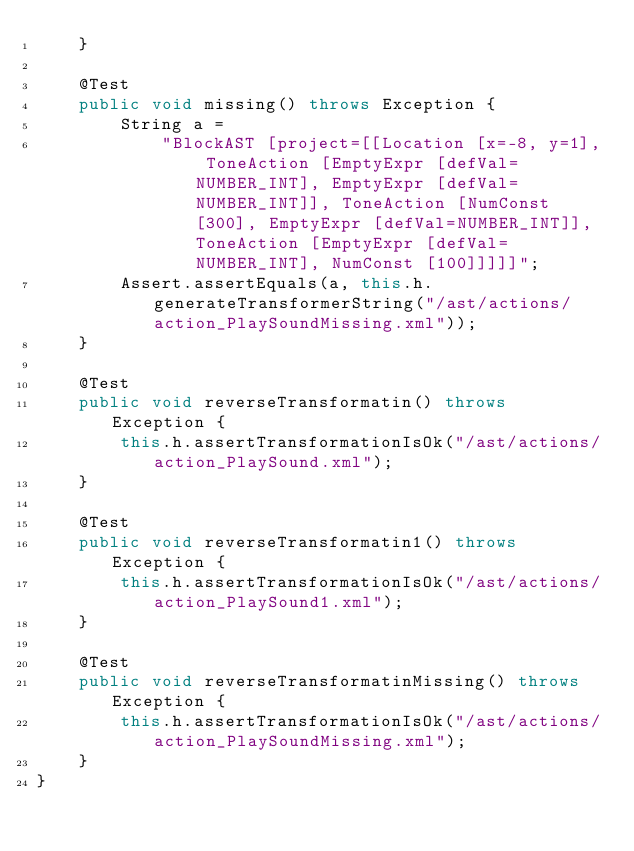<code> <loc_0><loc_0><loc_500><loc_500><_Java_>    }

    @Test
    public void missing() throws Exception {
        String a =
            "BlockAST [project=[[Location [x=-8, y=1], ToneAction [EmptyExpr [defVal=NUMBER_INT], EmptyExpr [defVal=NUMBER_INT]], ToneAction [NumConst [300], EmptyExpr [defVal=NUMBER_INT]], ToneAction [EmptyExpr [defVal=NUMBER_INT], NumConst [100]]]]]";
        Assert.assertEquals(a, this.h.generateTransformerString("/ast/actions/action_PlaySoundMissing.xml"));
    }

    @Test
    public void reverseTransformatin() throws Exception {
        this.h.assertTransformationIsOk("/ast/actions/action_PlaySound.xml");
    }

    @Test
    public void reverseTransformatin1() throws Exception {
        this.h.assertTransformationIsOk("/ast/actions/action_PlaySound1.xml");
    }

    @Test
    public void reverseTransformatinMissing() throws Exception {
        this.h.assertTransformationIsOk("/ast/actions/action_PlaySoundMissing.xml");
    }
}
</code> 